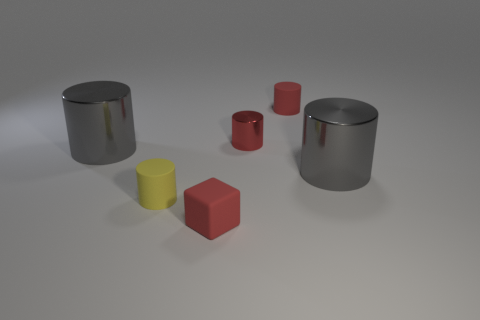How many gray objects are the same shape as the small yellow object?
Give a very brief answer. 2. What material is the cylinder that is in front of the red metal object and on the right side of the tiny red metallic object?
Provide a succinct answer. Metal. Is the material of the tiny yellow cylinder the same as the tiny red cube?
Make the answer very short. Yes. What number of large gray metal cylinders are there?
Make the answer very short. 2. What color is the large shiny object that is to the right of the tiny matte cylinder behind the big cylinder that is right of the yellow rubber cylinder?
Offer a terse response. Gray. Is the tiny metal object the same color as the rubber cube?
Make the answer very short. Yes. What number of small rubber things are behind the small shiny cylinder and on the left side of the red block?
Your answer should be very brief. 0. How many rubber things are yellow cylinders or blocks?
Give a very brief answer. 2. The tiny red cylinder in front of the small red cylinder that is on the right side of the small red metal object is made of what material?
Offer a terse response. Metal. There is a rubber thing that is the same color as the small matte cube; what is its shape?
Give a very brief answer. Cylinder. 